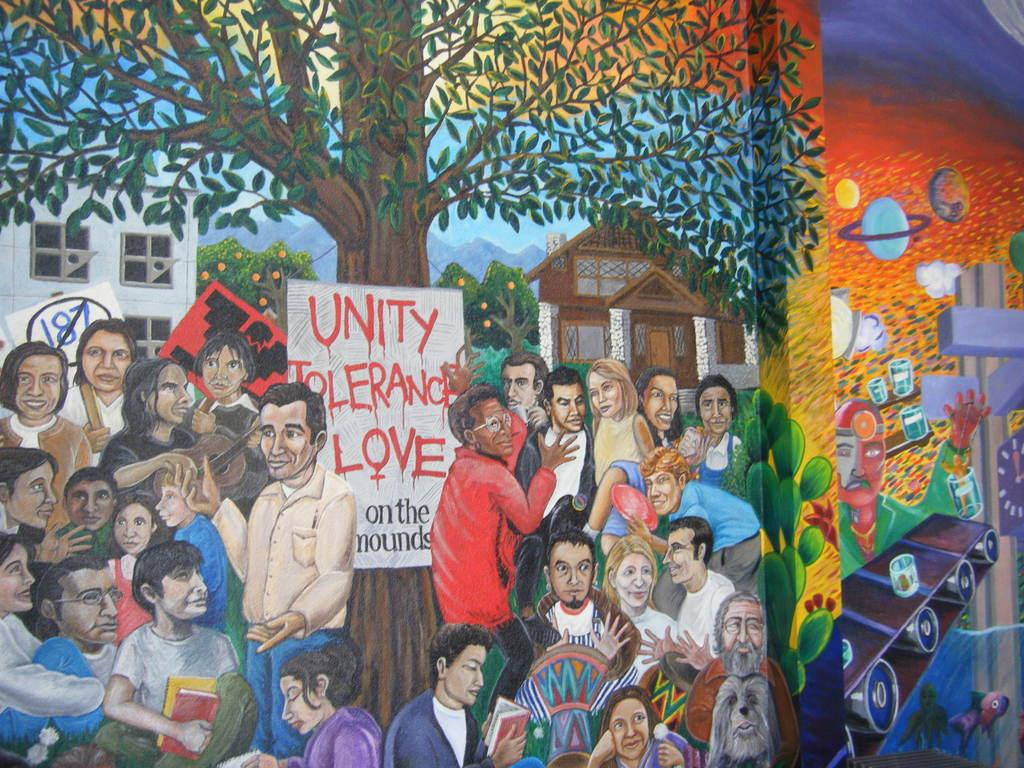What is on the wall in the image? There is a painting on the wall in the image. What type of dinner is being served in the image? There is no dinner present in the image; it only features a painting on the wall. Can you tell me how many fans are visible in the image? There are no fans present in the image; it only features a painting on the wall. 